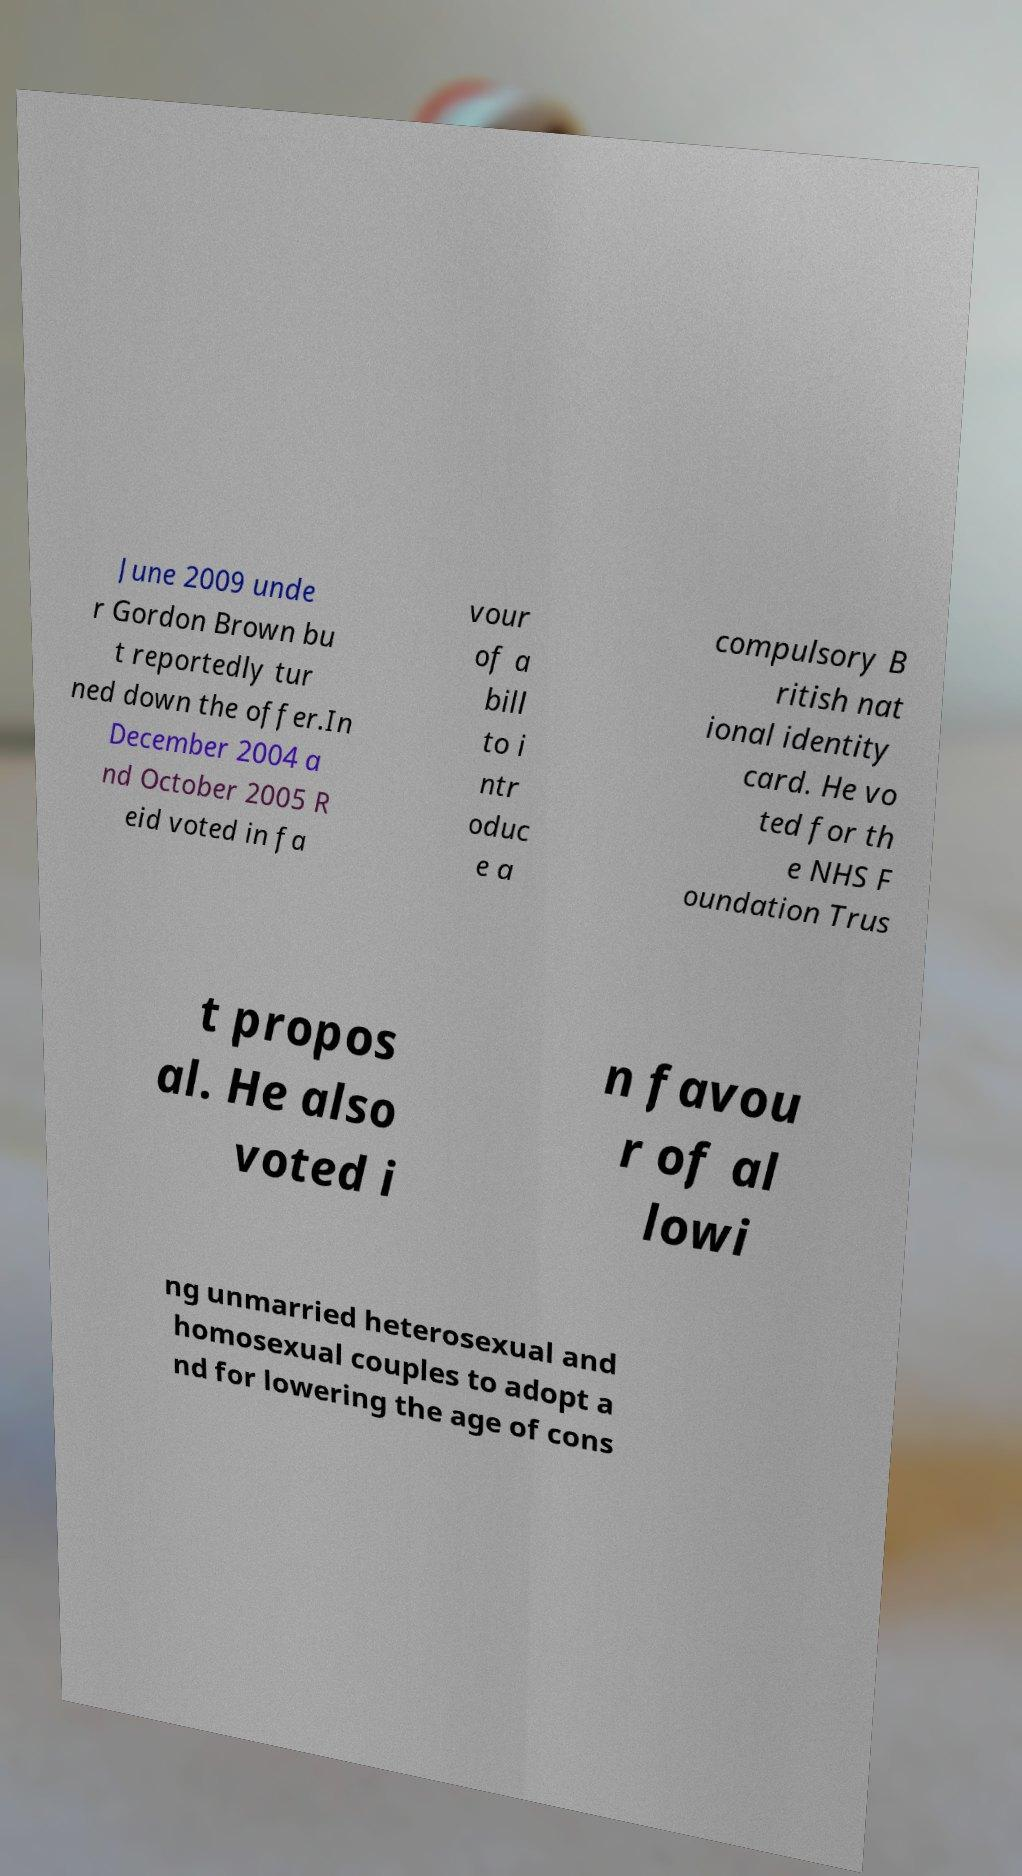There's text embedded in this image that I need extracted. Can you transcribe it verbatim? June 2009 unde r Gordon Brown bu t reportedly tur ned down the offer.In December 2004 a nd October 2005 R eid voted in fa vour of a bill to i ntr oduc e a compulsory B ritish nat ional identity card. He vo ted for th e NHS F oundation Trus t propos al. He also voted i n favou r of al lowi ng unmarried heterosexual and homosexual couples to adopt a nd for lowering the age of cons 